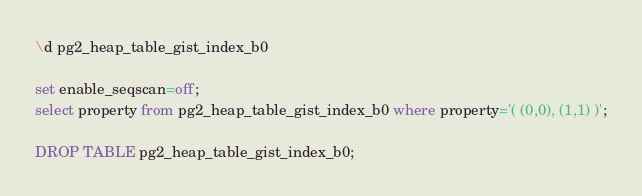Convert code to text. <code><loc_0><loc_0><loc_500><loc_500><_SQL_>\d pg2_heap_table_gist_index_b0

set enable_seqscan=off;
select property from pg2_heap_table_gist_index_b0 where property='( (0,0), (1,1) )';

DROP TABLE pg2_heap_table_gist_index_b0;
</code> 